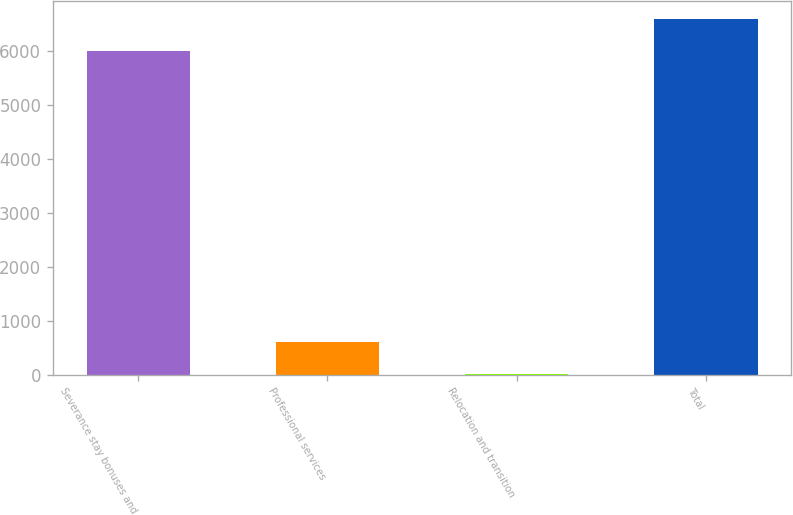Convert chart to OTSL. <chart><loc_0><loc_0><loc_500><loc_500><bar_chart><fcel>Severance stay bonuses and<fcel>Professional services<fcel>Relocation and transition<fcel>Total<nl><fcel>5991<fcel>604.41<fcel>4.12<fcel>6591.29<nl></chart> 